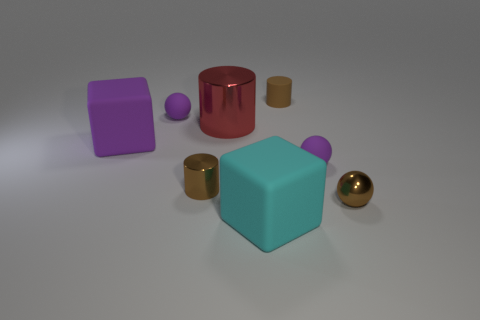Subtract all green balls. Subtract all cyan cylinders. How many balls are left? 3 Subtract all blocks. How many objects are left? 6 Subtract 0 blue blocks. How many objects are left? 8 Subtract all tiny blue rubber blocks. Subtract all red cylinders. How many objects are left? 7 Add 7 tiny metallic spheres. How many tiny metallic spheres are left? 8 Add 2 small matte cylinders. How many small matte cylinders exist? 3 